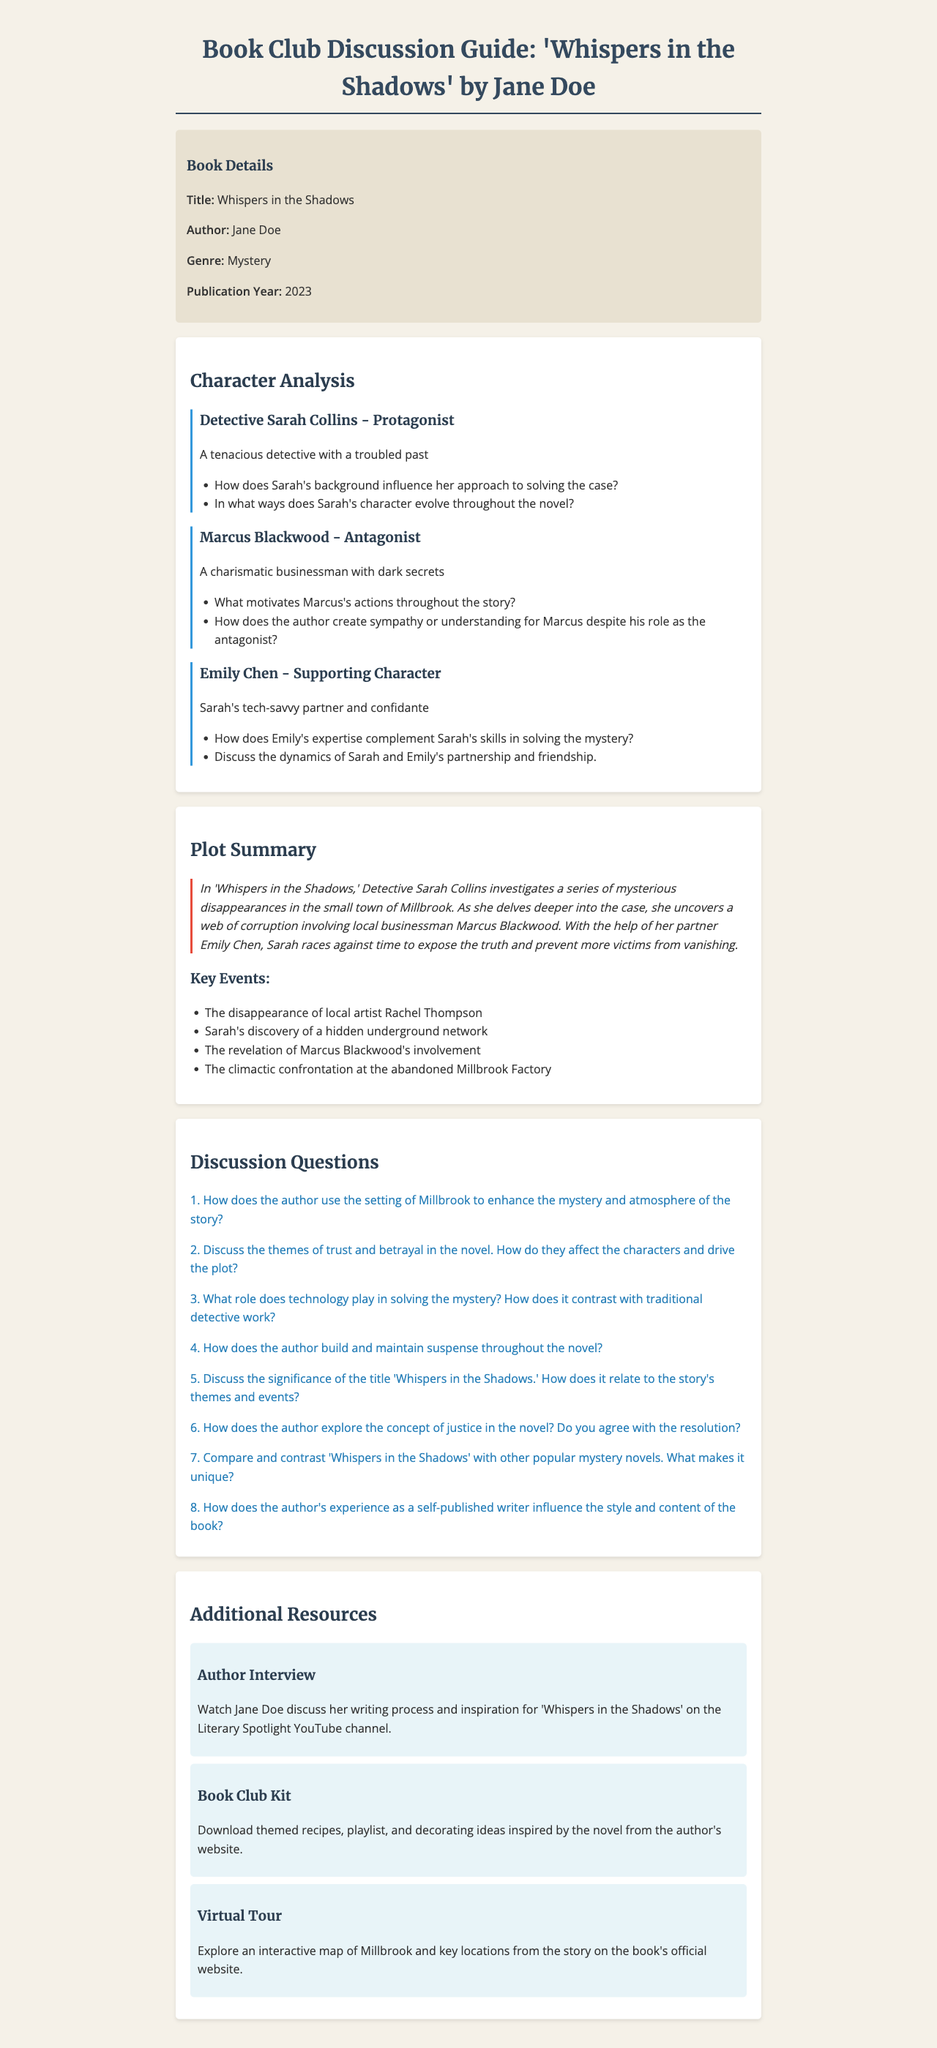What is the title of the book? The title of the book is mentioned in the document as the main title.
Answer: Whispers in the Shadows Who is the author of the book? The author of the book is explicitly stated in the book details section of the document.
Answer: Jane Doe What is the publication year of the book? The publication year is specified in the book details section.
Answer: 2023 How many key events are listed in the plot summary? The document lists specific key events in the plot summary section.
Answer: Four What role does Detective Sarah Collins play in the story? The character's role is described in the character analysis section of the document.
Answer: Protagonist What is the significance of the title "Whispers in the Shadows"? This question relates to understanding themes and events in the story, requiring reasoning about the title's relevance.
Answer: Discuss the significance of the title What motivates Marcus Blackwood in the story? This question requires synthesizing information from the character analysis about Marcus's character.
Answer: What motivates Marcus's actions? What is the main theme discussed in the discussion questions? The document includes themes in the discussion questions section, which need understanding of the content.
Answer: Trust and betrayal What additional resource discusses the author's writing process? The additional resources section specifies resources related to the author, including her interviews.
Answer: Author Interview 